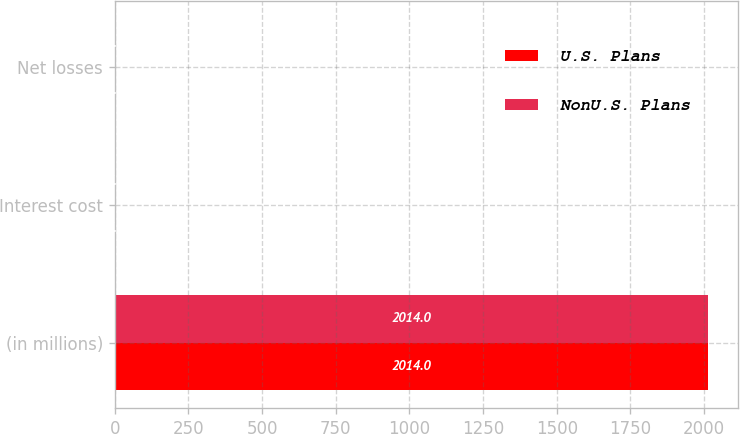<chart> <loc_0><loc_0><loc_500><loc_500><stacked_bar_chart><ecel><fcel>(in millions)<fcel>Interest cost<fcel>Net losses<nl><fcel>U.S. Plans<fcel>2014<fcel>5<fcel>1<nl><fcel>NonU.S. Plans<fcel>2014<fcel>5<fcel>1<nl></chart> 